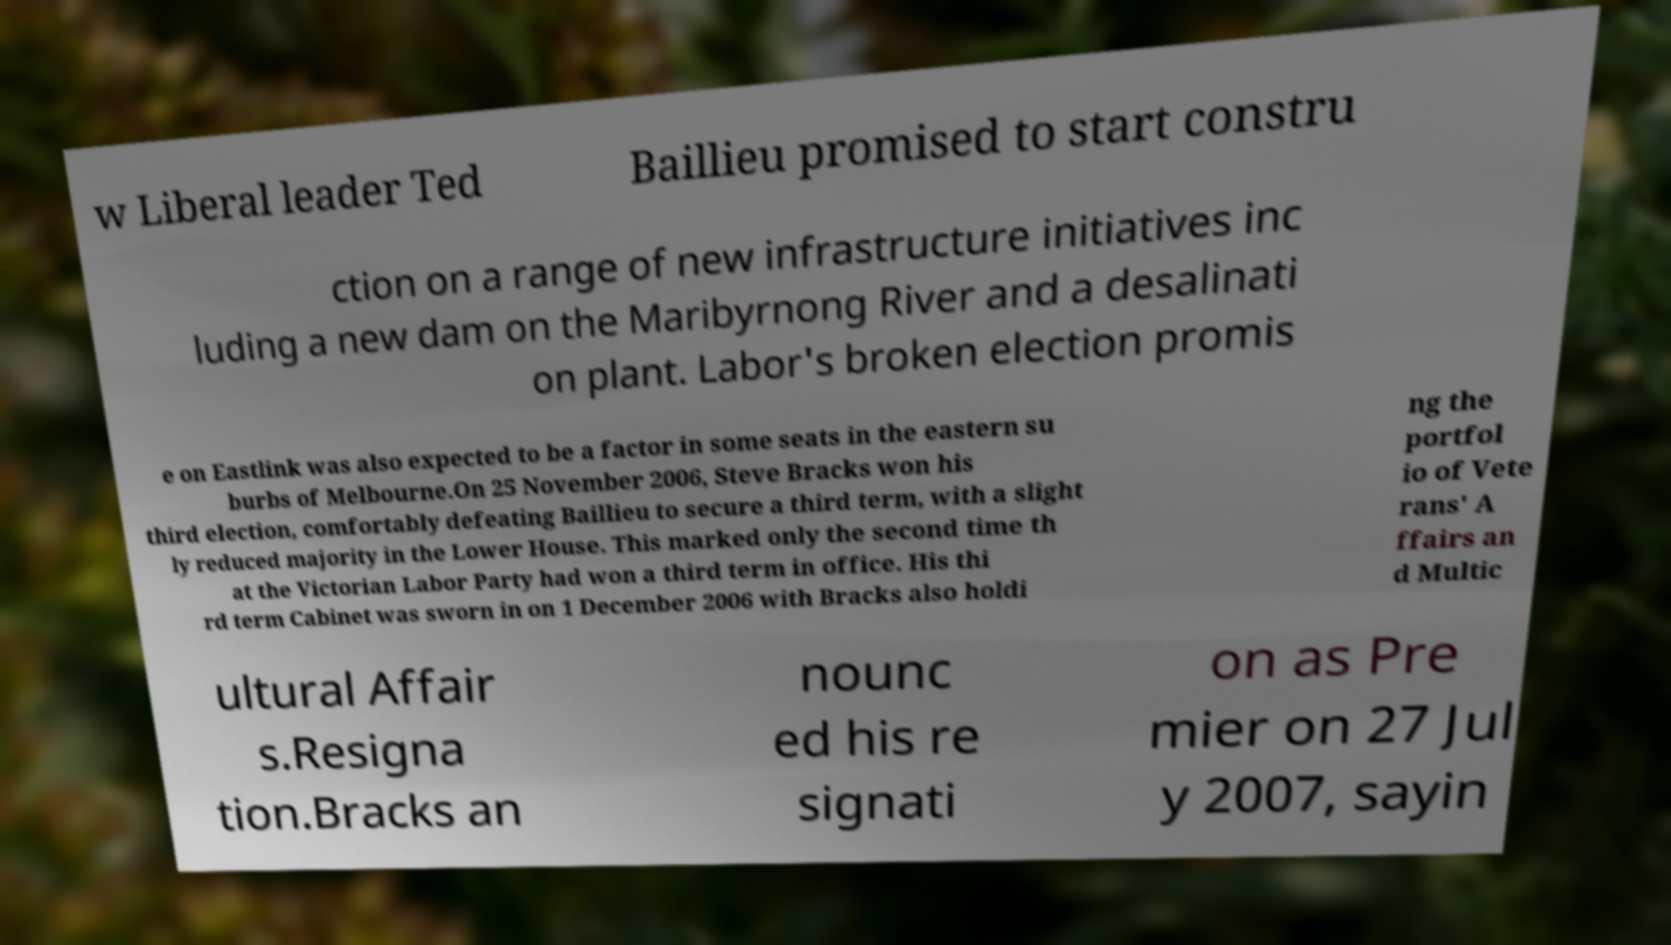Could you assist in decoding the text presented in this image and type it out clearly? w Liberal leader Ted Baillieu promised to start constru ction on a range of new infrastructure initiatives inc luding a new dam on the Maribyrnong River and a desalinati on plant. Labor's broken election promis e on Eastlink was also expected to be a factor in some seats in the eastern su burbs of Melbourne.On 25 November 2006, Steve Bracks won his third election, comfortably defeating Baillieu to secure a third term, with a slight ly reduced majority in the Lower House. This marked only the second time th at the Victorian Labor Party had won a third term in office. His thi rd term Cabinet was sworn in on 1 December 2006 with Bracks also holdi ng the portfol io of Vete rans' A ffairs an d Multic ultural Affair s.Resigna tion.Bracks an nounc ed his re signati on as Pre mier on 27 Jul y 2007, sayin 